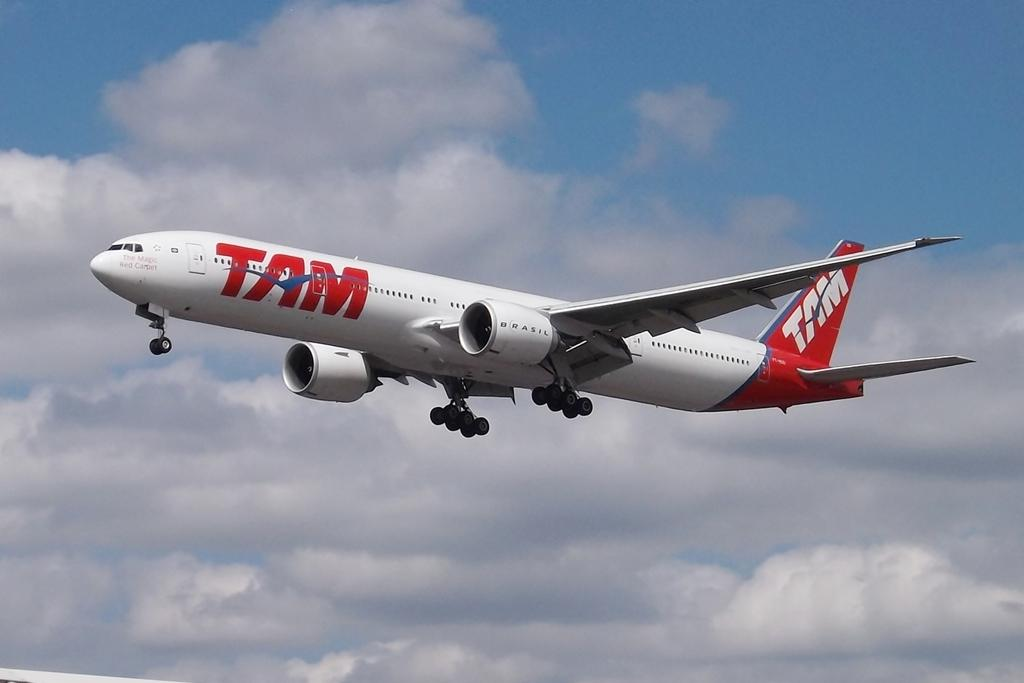Provide a one-sentence caption for the provided image. A TAM airlines plane takes flight into the sky. 